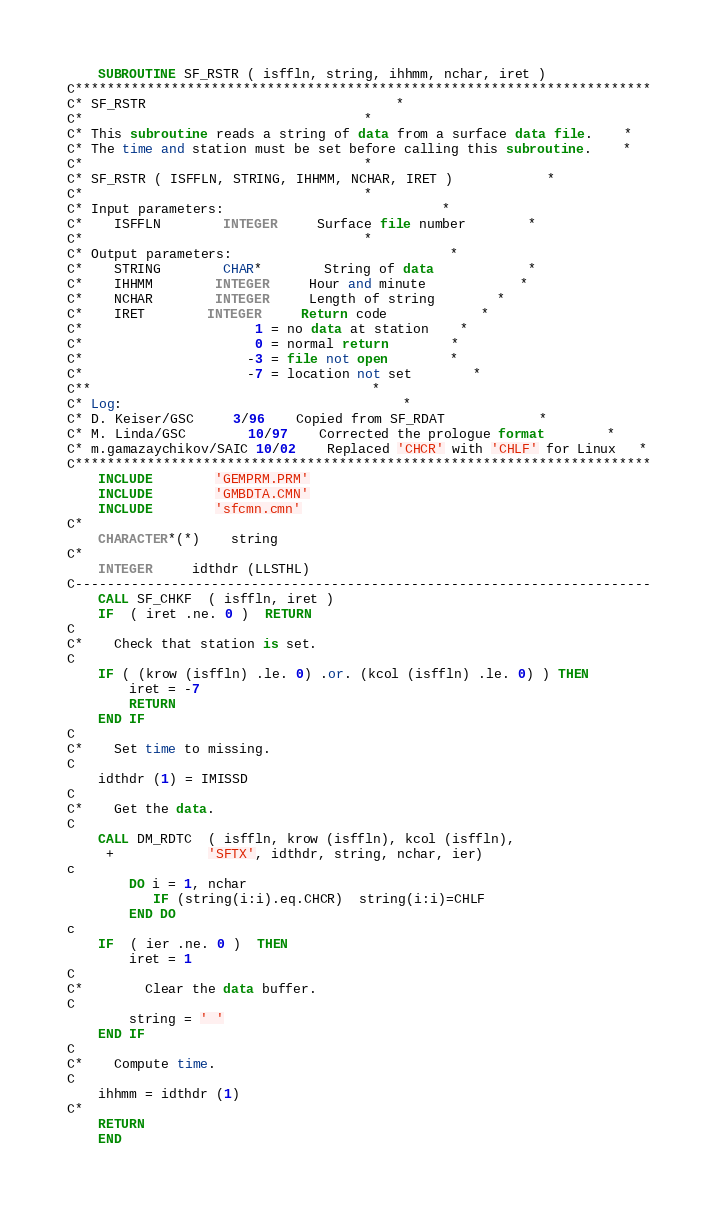<code> <loc_0><loc_0><loc_500><loc_500><_FORTRAN_>	SUBROUTINE SF_RSTR ( isffln, string, ihhmm, nchar, iret )
C************************************************************************
C* SF_RSTR								*
C*									*
C* This subroutine reads a string of data from a surface data file.	*
C* The time and	station must be set before calling this subroutine.	*
C*									*
C* SF_RSTR ( ISFFLN, STRING, IHHMM, NCHAR, IRET )			*
C*									*
C* Input parameters:							*
C*	ISFFLN		INTEGER		Surface file number		*
C*									*
C* Output parameters:							*
C*	STRING		CHAR*		String of data			*
C*	IHHMM		INTEGER		Hour and minute			*
C*	NCHAR		INTEGER		Length of string		*
C*	IRET		INTEGER		Return code			*
C*					  1 = no data at station	*
C*					  0 = normal return		*
C*					 -3 = file not open		*
C*					 -7 = location not set		*
C**									*
C* Log:									*
C* D. Keiser/GSC	 3/96	Copied from SF_RDAT			*
C* M. Linda/GSC		10/97	Corrected the prologue format		*
C* m.gamazaychikov/SAIC 10/02	Replaced 'CHCR' with 'CHLF' for Linux   *
C************************************************************************
	INCLUDE		'GEMPRM.PRM'
	INCLUDE		'GMBDTA.CMN'
	INCLUDE		'sfcmn.cmn'
C*
	CHARACTER*(*)	string
C*
	INTEGER		idthdr (LLSTHL)
C------------------------------------------------------------------------
	CALL SF_CHKF  ( isffln, iret )
	IF  ( iret .ne. 0 )  RETURN
C
C*	Check that station is set.
C
	IF ( (krow (isffln) .le. 0) .or. (kcol (isffln) .le. 0) ) THEN
	    iret = -7
	    RETURN
	END IF
C
C*	Set time to missing.
C
	idthdr (1) = IMISSD
C
C*	Get the data.
C
	CALL DM_RDTC  ( isffln, krow (isffln), kcol (isffln),
     +			'SFTX', idthdr, string, nchar, ier)
c
        DO i = 1, nchar
           IF (string(i:i).eq.CHCR)  string(i:i)=CHLF
        END DO
c
	IF  ( ier .ne. 0 )  THEN
	    iret = 1
C
C*	    Clear the data buffer.
C
	    string = ' '
	END IF
C
C*	Compute time.
C
	ihhmm = idthdr (1)
C*
	RETURN
	END
</code> 